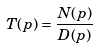Convert formula to latex. <formula><loc_0><loc_0><loc_500><loc_500>T ( p ) = \frac { N ( p ) } { D ( p ) }</formula> 